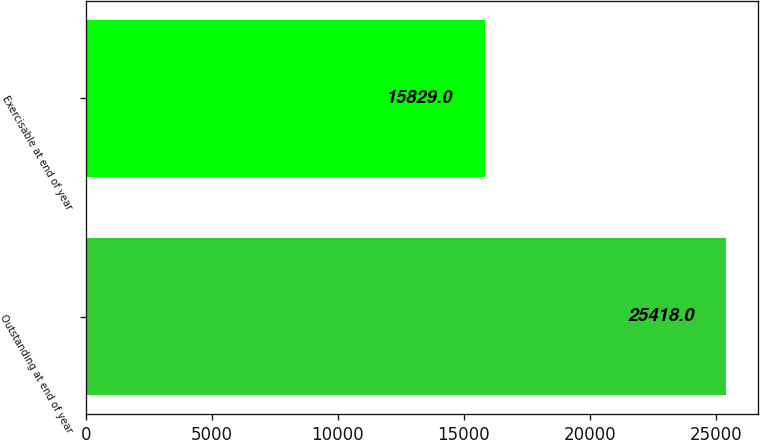<chart> <loc_0><loc_0><loc_500><loc_500><bar_chart><fcel>Outstanding at end of year<fcel>Exercisable at end of year<nl><fcel>25418<fcel>15829<nl></chart> 